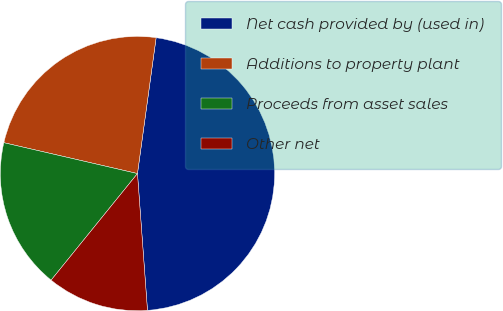Convert chart. <chart><loc_0><loc_0><loc_500><loc_500><pie_chart><fcel>Net cash provided by (used in)<fcel>Additions to property plant<fcel>Proceeds from asset sales<fcel>Other net<nl><fcel>46.67%<fcel>23.56%<fcel>17.78%<fcel>12.0%<nl></chart> 